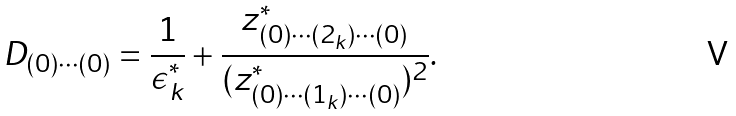Convert formula to latex. <formula><loc_0><loc_0><loc_500><loc_500>D _ { ( 0 ) \cdots ( 0 ) } = \frac { 1 } { \epsilon _ { k } ^ { * } } + \frac { z _ { ( 0 ) \cdots ( 2 _ { k } ) \cdots ( 0 ) } ^ { * } } { ( z _ { ( 0 ) \cdots ( 1 _ { k } ) \cdots ( 0 ) } ^ { * } ) ^ { 2 } } .</formula> 